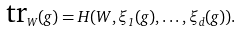<formula> <loc_0><loc_0><loc_500><loc_500>\text {tr} _ { W } ( g ) = H ( W , \xi _ { 1 } ( g ) , \dots , \xi _ { d } ( g ) ) .</formula> 